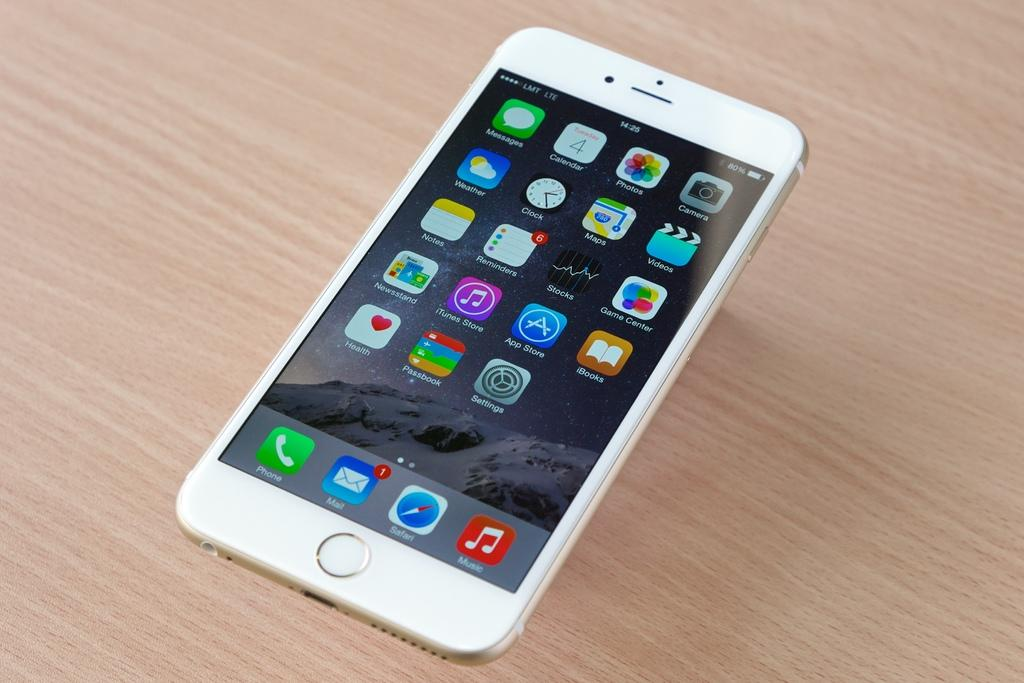<image>
Present a compact description of the photo's key features. At time 14:25, the cell phone was at 80% battery. 